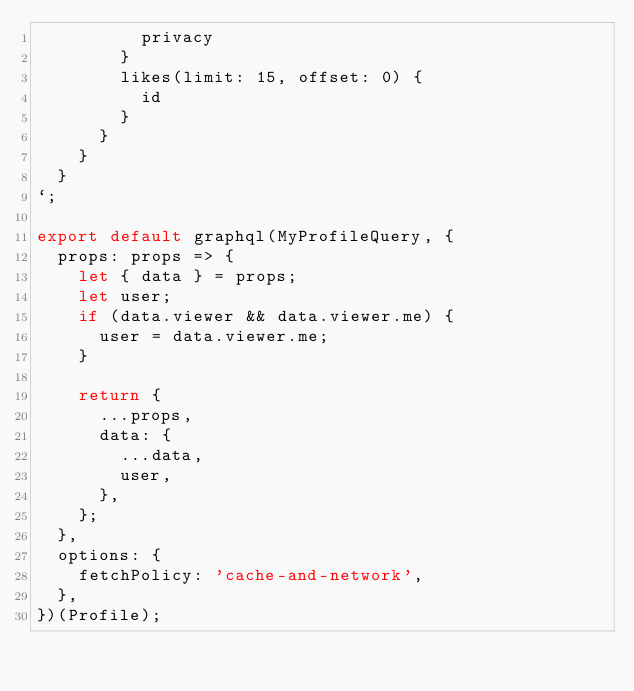Convert code to text. <code><loc_0><loc_0><loc_500><loc_500><_JavaScript_>          privacy
        }
        likes(limit: 15, offset: 0) {
          id
        }
      }
    }
  }
`;

export default graphql(MyProfileQuery, {
  props: props => {
    let { data } = props;
    let user;
    if (data.viewer && data.viewer.me) {
      user = data.viewer.me;
    }

    return {
      ...props,
      data: {
        ...data,
        user,
      },
    };
  },
  options: {
    fetchPolicy: 'cache-and-network',
  },
})(Profile);
</code> 